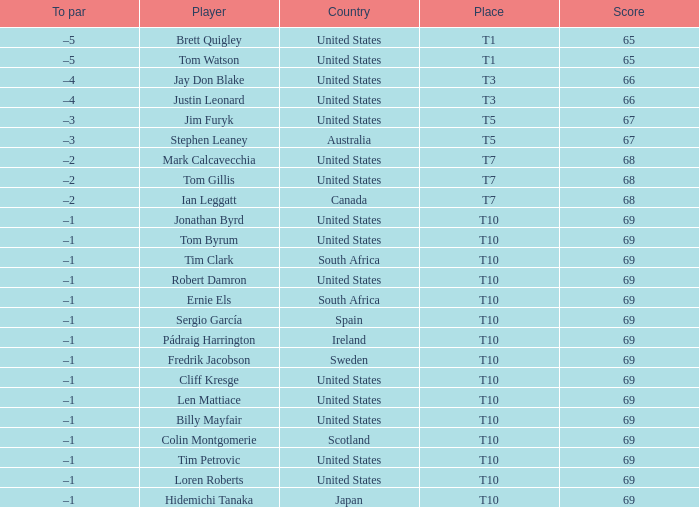What is the average score for the player who is T5 in the United States? 67.0. 